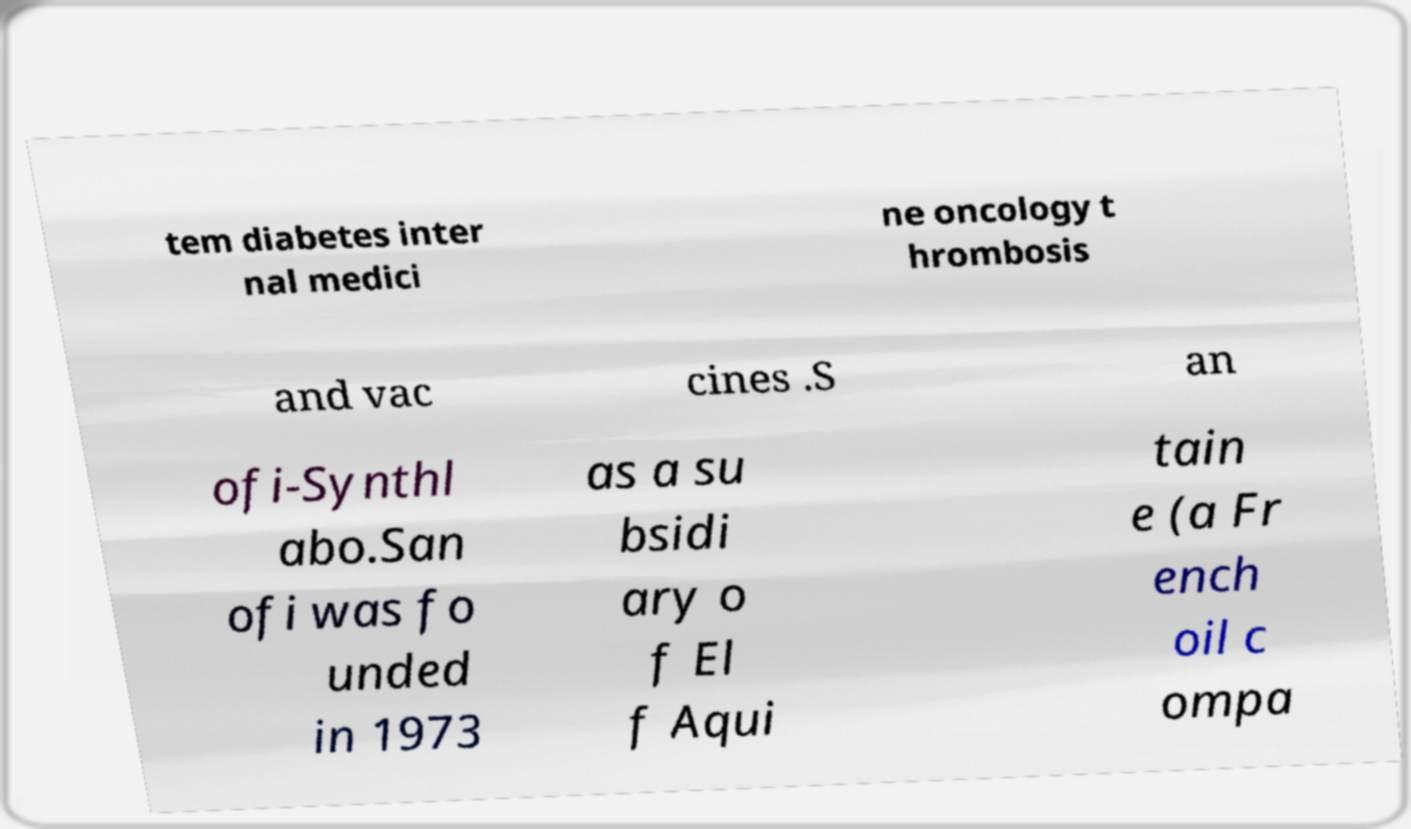Please read and relay the text visible in this image. What does it say? tem diabetes inter nal medici ne oncology t hrombosis and vac cines .S an ofi-Synthl abo.San ofi was fo unded in 1973 as a su bsidi ary o f El f Aqui tain e (a Fr ench oil c ompa 